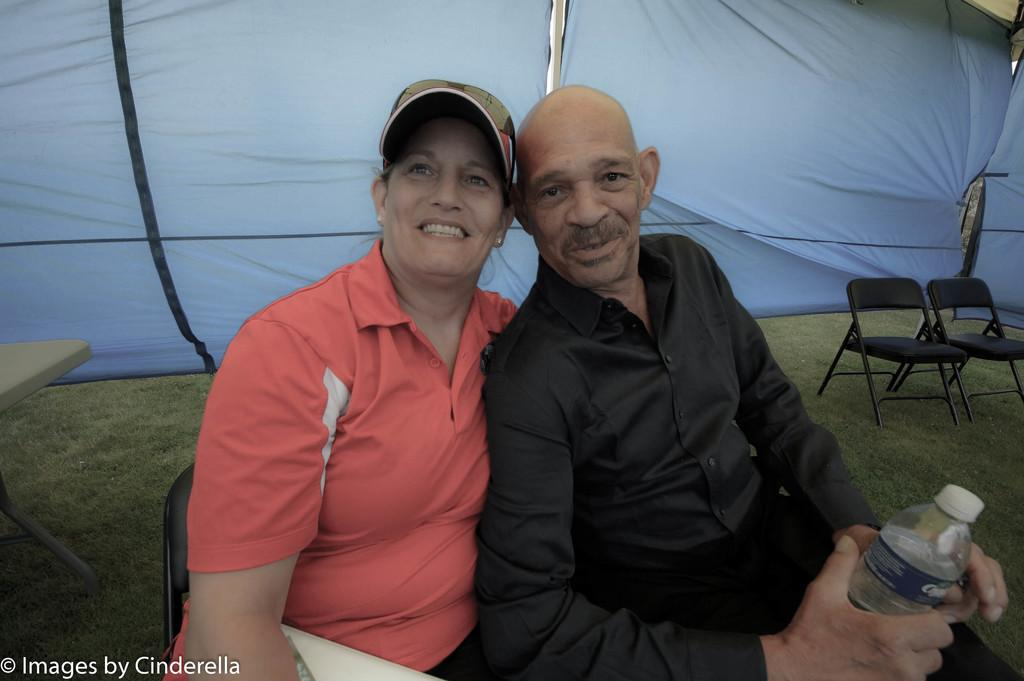Who are the people in the image? There is a woman and a man in the image. What is the woman wearing on her head? The woman is wearing a cap. What is the man holding in the image? The man is holding a bottle. What type of furniture can be seen in the image? There are chairs and a table in the image. What is the ground surface made of in the image? There is grass in the image. What type of bone is visible on the table in the image? There is no bone present on the table in the image. How many cushions are on the chairs in the image? There is no mention of cushions on the chairs in the image. 